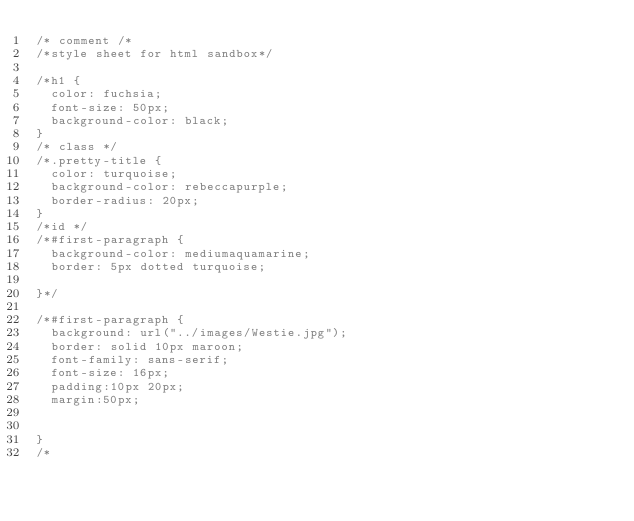<code> <loc_0><loc_0><loc_500><loc_500><_CSS_>/* comment /*
/*style sheet for html sandbox*/

/*h1 {
	color: fuchsia;
	font-size: 50px;
	background-color: black;
}
/* class */
/*.pretty-title {
	color: turquoise;
	background-color: rebeccapurple;
	border-radius: 20px;
}
/*id */
/*#first-paragraph {
	background-color: mediumaquamarine;
	border: 5px dotted turquoise;

}*/

/*#first-paragraph {
	background: url("../images/Westie.jpg");
	border: solid 10px maroon;
	font-family: sans-serif;
	font-size: 16px;
	padding:10px 20px;
	margin:50px;


}
/*</code> 